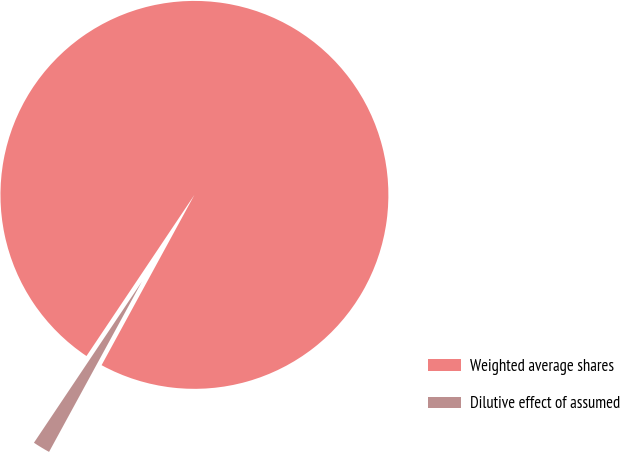<chart> <loc_0><loc_0><loc_500><loc_500><pie_chart><fcel>Weighted average shares<fcel>Dilutive effect of assumed<nl><fcel>98.55%<fcel>1.45%<nl></chart> 